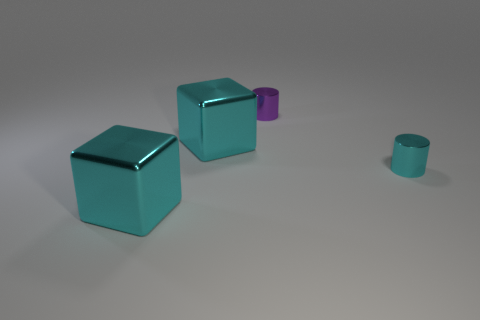How would you describe the texture and material of the cyan cube in relation to the smaller objects? The texture of the cyan cube appears to be smooth with a metallic sheen, indicating it might be made of metal or a similar material. This gives it a lustrous quality that contrasts with the more matte finish of the objects beside it. Are there any reflections or shadows cast by the objects that provide hints about the light source? Indeed, there are subtle shadows beneath each object and highlights on their surfaces that suggest a light source above and to the left. The reflections on the cubes, especially, help deduce the angle and diffusion of the light. 